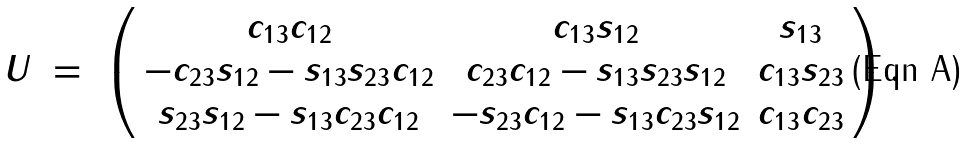Convert formula to latex. <formula><loc_0><loc_0><loc_500><loc_500>U \ = \ \left ( \begin{array} { c c c } c _ { 1 3 } c _ { 1 2 } & c _ { 1 3 } s _ { 1 2 } & s _ { 1 3 } \\ - c _ { 2 3 } s _ { 1 2 } - s _ { 1 3 } s _ { 2 3 } c _ { 1 2 } & c _ { 2 3 } c _ { 1 2 } - s _ { 1 3 } s _ { 2 3 } s _ { 1 2 } & c _ { 1 3 } s _ { 2 3 } \\ s _ { 2 3 } s _ { 1 2 } - s _ { 1 3 } c _ { 2 3 } c _ { 1 2 } & - s _ { 2 3 } c _ { 1 2 } - s _ { 1 3 } c _ { 2 3 } s _ { 1 2 } & c _ { 1 3 } c _ { 2 3 } \end{array} \right ) .</formula> 